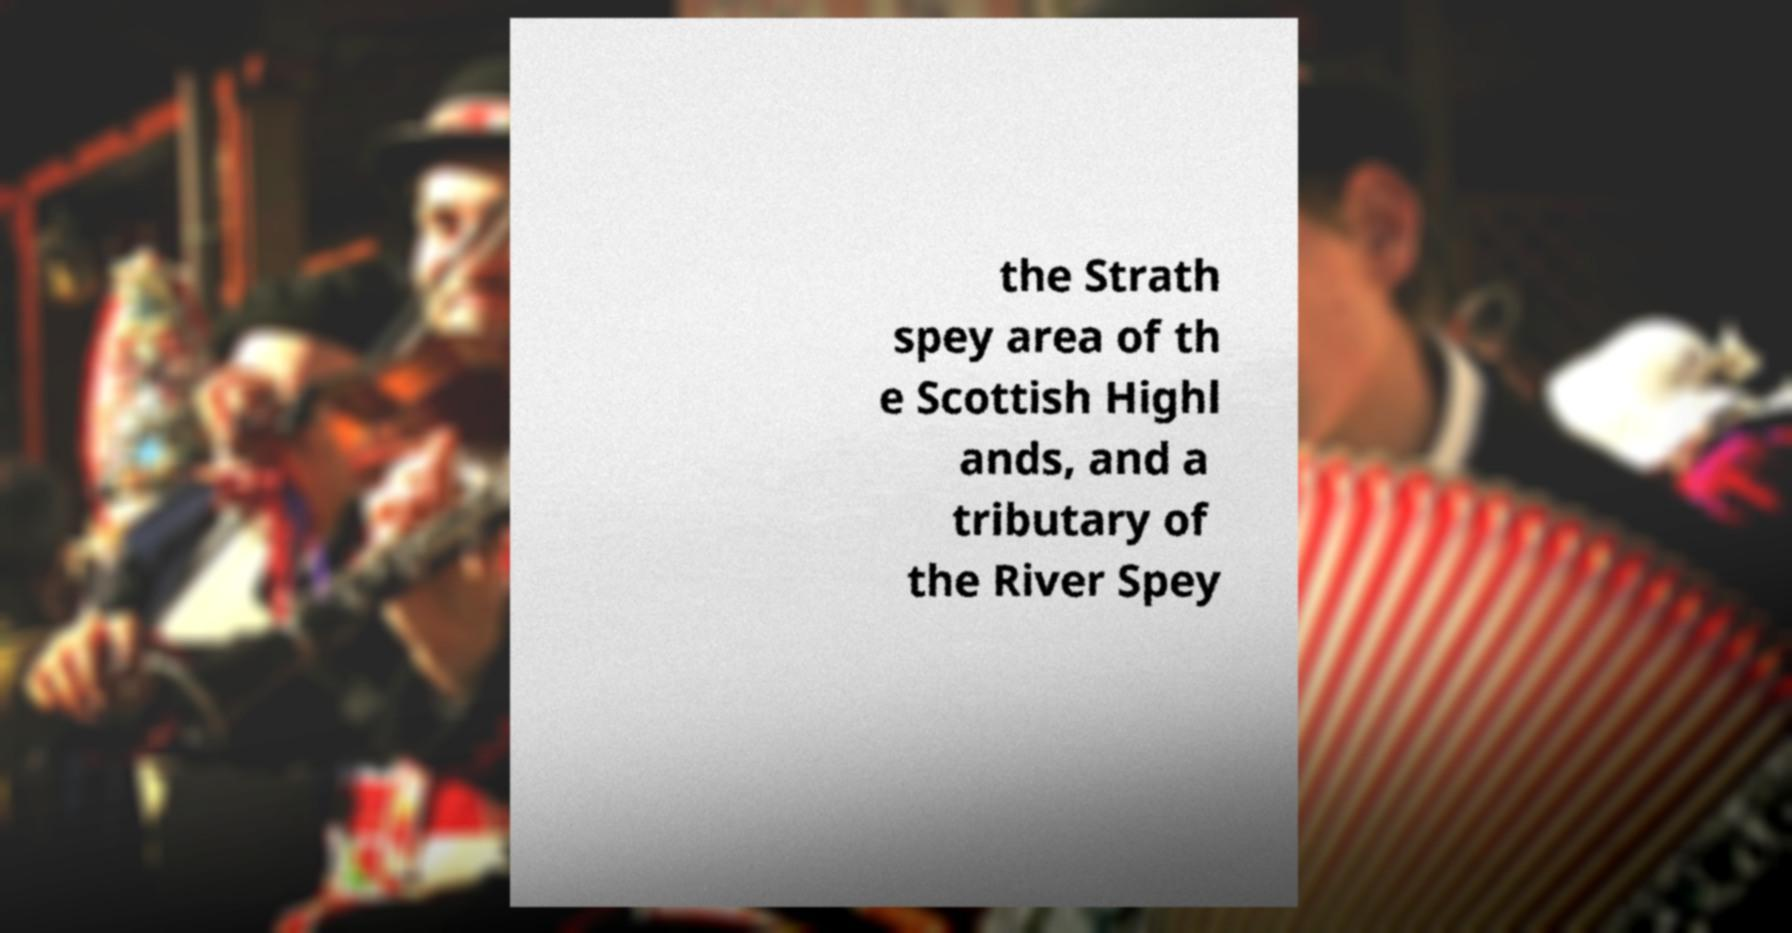There's text embedded in this image that I need extracted. Can you transcribe it verbatim? the Strath spey area of th e Scottish Highl ands, and a tributary of the River Spey 